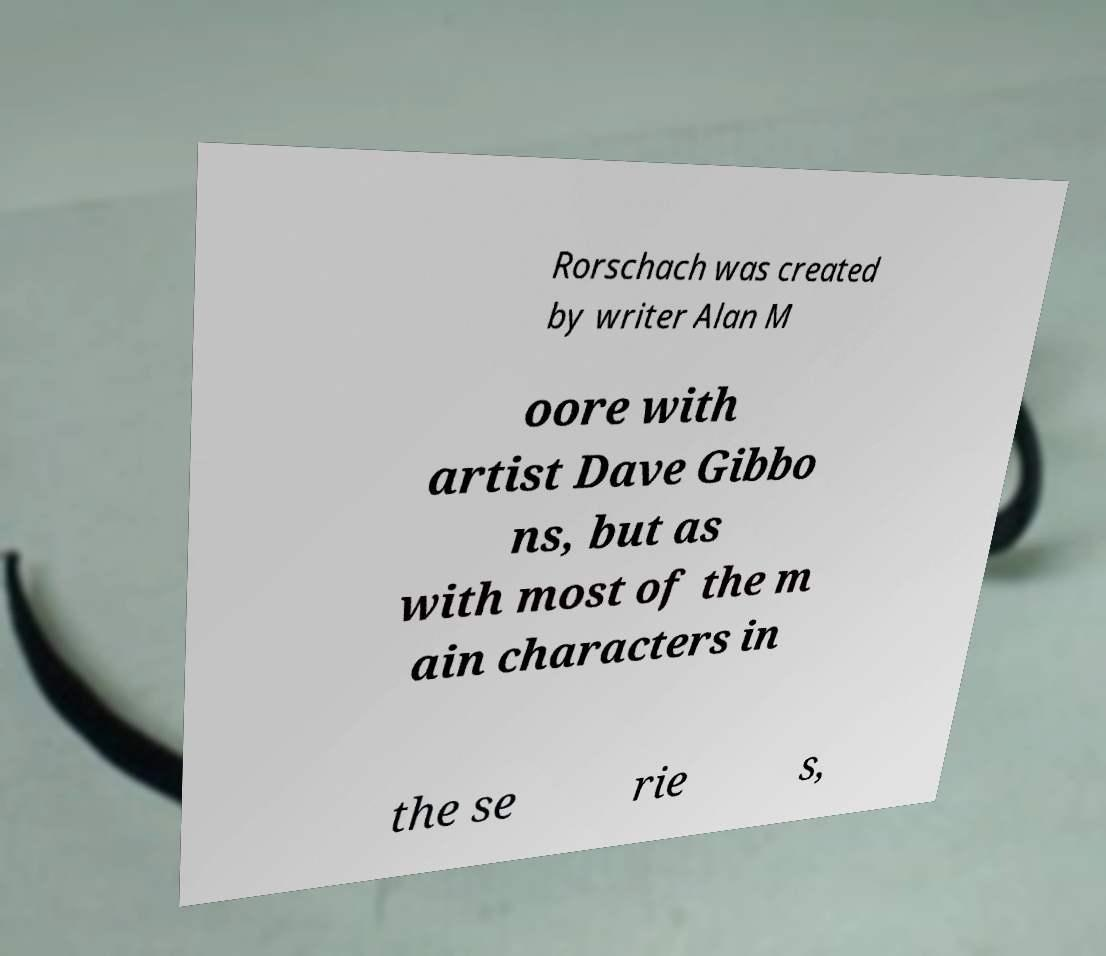Can you accurately transcribe the text from the provided image for me? Rorschach was created by writer Alan M oore with artist Dave Gibbo ns, but as with most of the m ain characters in the se rie s, 